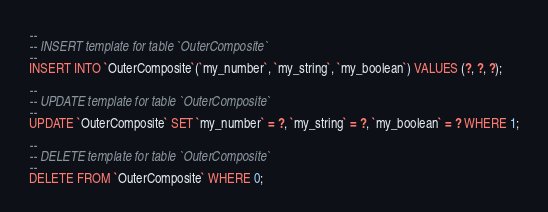Convert code to text. <code><loc_0><loc_0><loc_500><loc_500><_SQL_>--
-- INSERT template for table `OuterComposite`
--
INSERT INTO `OuterComposite`(`my_number`, `my_string`, `my_boolean`) VALUES (?, ?, ?);

--
-- UPDATE template for table `OuterComposite`
--
UPDATE `OuterComposite` SET `my_number` = ?, `my_string` = ?, `my_boolean` = ? WHERE 1;

--
-- DELETE template for table `OuterComposite`
--
DELETE FROM `OuterComposite` WHERE 0;

</code> 